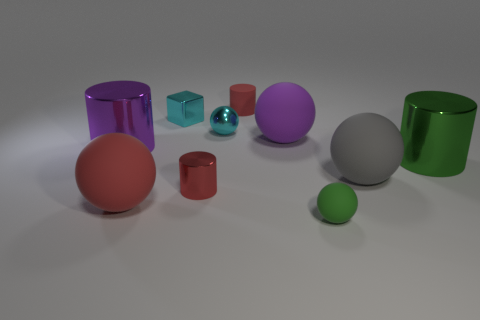Can you describe the lightning and shadows present in the image? The lighting in the image is soft and diffuse, implying an environment with either overcast lighting or soft box lighting from above. Shadows are subtle and fall mostly to the right of the objects, which would suggest a light source positioned to the left of the scene. The softness of the shadows suggests that the light source is not overly focused, contributing to the tranquil mood of the image. 